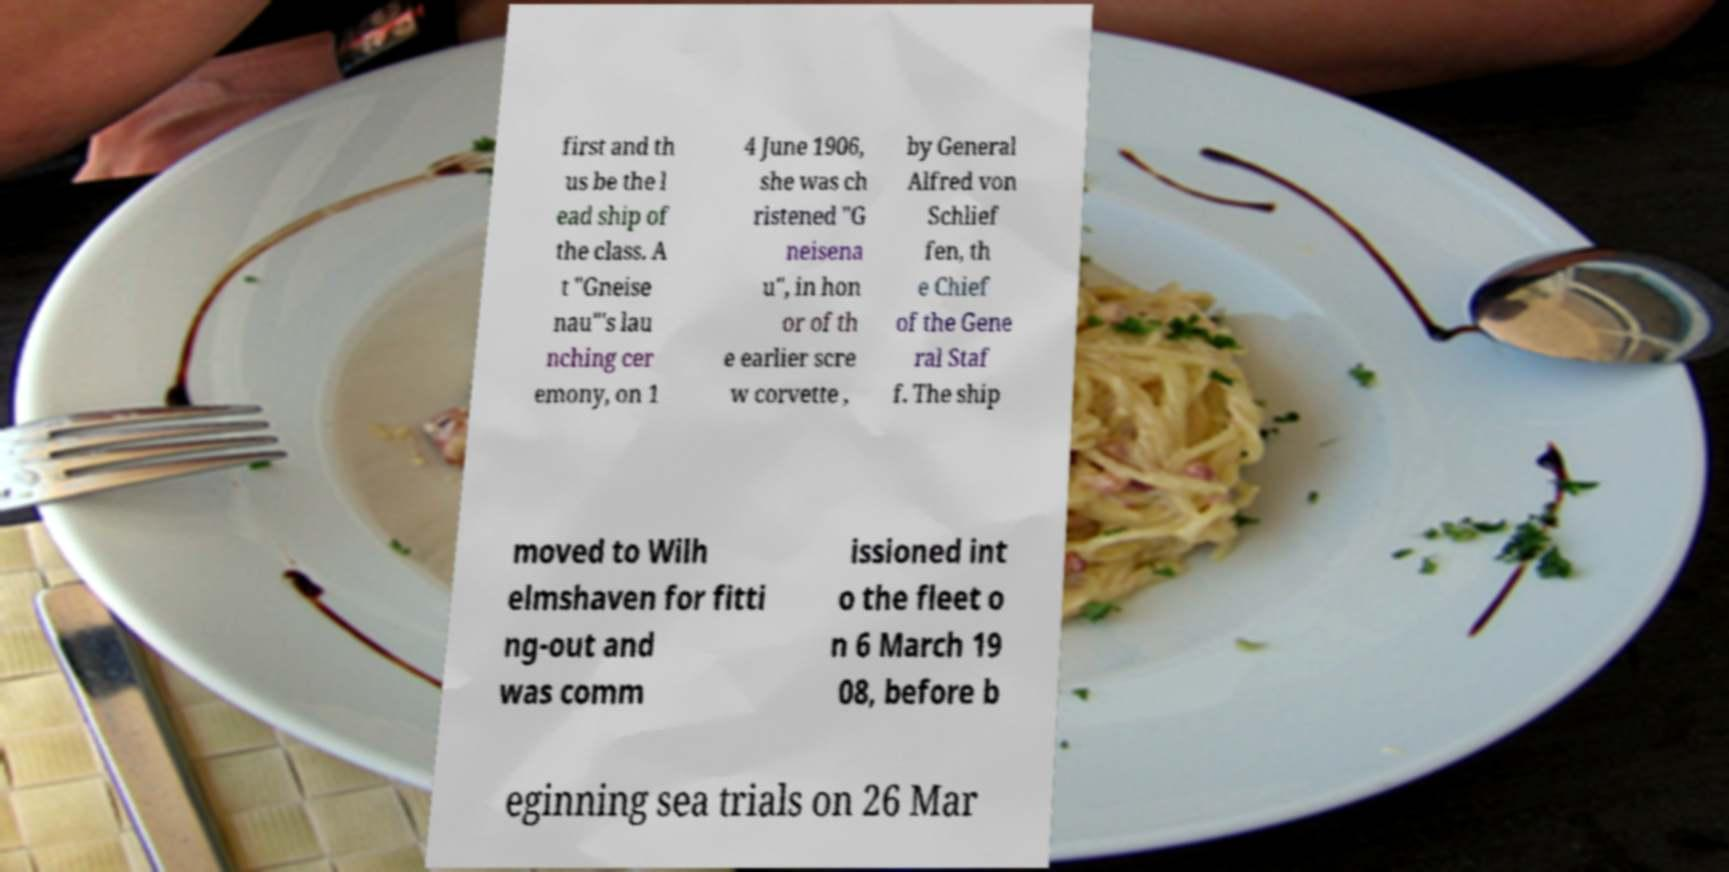Could you extract and type out the text from this image? first and th us be the l ead ship of the class. A t "Gneise nau"'s lau nching cer emony, on 1 4 June 1906, she was ch ristened "G neisena u", in hon or of th e earlier scre w corvette , by General Alfred von Schlief fen, th e Chief of the Gene ral Staf f. The ship moved to Wilh elmshaven for fitti ng-out and was comm issioned int o the fleet o n 6 March 19 08, before b eginning sea trials on 26 Mar 